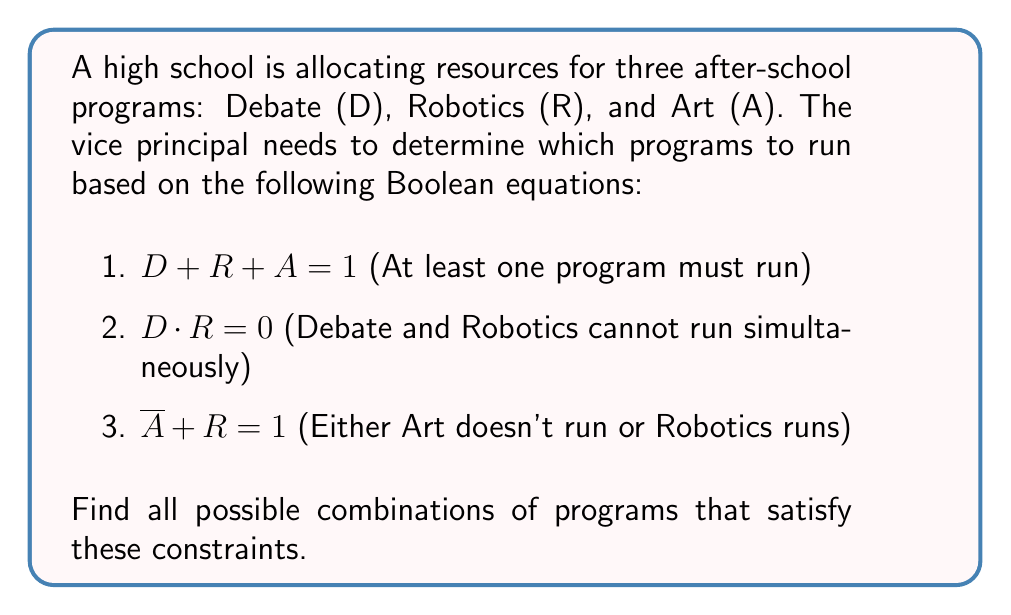What is the answer to this math problem? Let's solve this system of Boolean equations step by step:

1) From equation 2: $D \cdot R = 0$
   This means D and R cannot both be 1. The possible combinations are:
   (D, R) = (0, 0), (0, 1), or (1, 0)

2) From equation 3: $\overline{A} + R = 1$
   This can be rewritten as: $A \leq R$ (A implies R)
   So if A is 1, R must be 1; if R is 0, A must be 0

3) Combining the information from steps 1 and 2:
   - If R = 1, then D = 0 and A can be either 0 or 1
   - If R = 0, then A must be 0, and D can be either 0 or 1

4) Now, let's check these combinations against equation 1: $D + R + A = 1$
   This means at least one program must run.

5) The possible combinations satisfying all equations are:
   (D, R, A) = (0, 1, 0), (0, 1, 1), (1, 0, 0)

These combinations represent:
- Robotics only
- Robotics and Art
- Debate only
Answer: (0, 1, 0), (0, 1, 1), (1, 0, 0) 